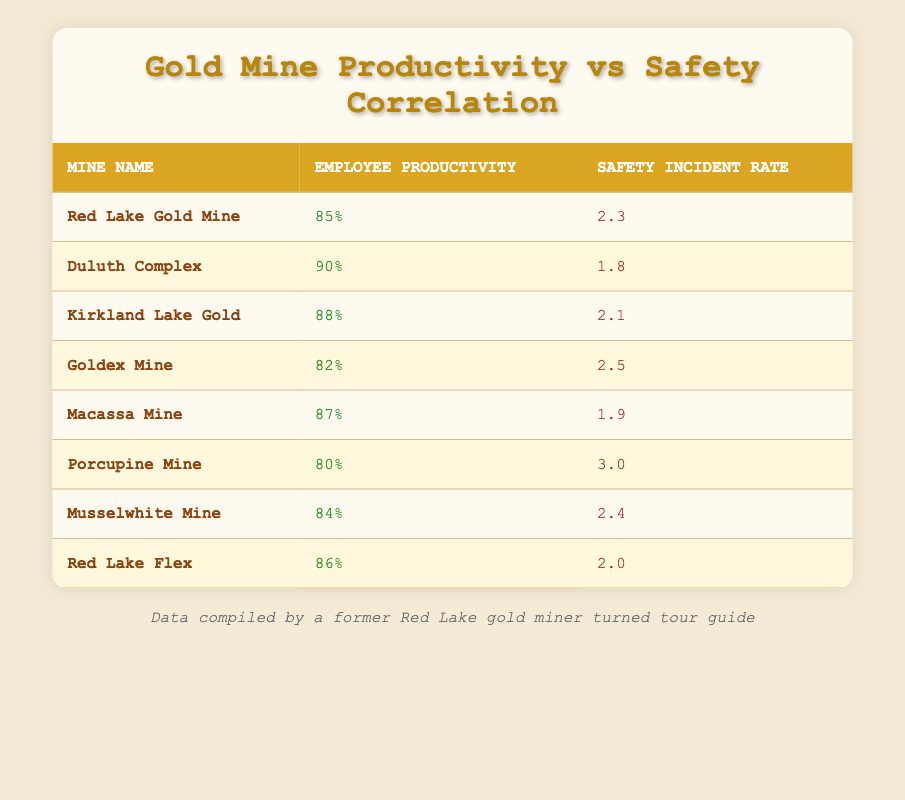What is the employee productivity percentage at Red Lake Gold Mine? The table lists the productivity for each mine. For Red Lake Gold Mine, the employee productivity is noted as 85%.
Answer: 85% Which mine has the lowest safety incident rate? By reviewing the safety incident rates in the table, Duluth Complex has the lowest rate at 1.8 incidents.
Answer: Duluth Complex What is the average employee productivity across all mines? To calculate the average, sum the productivity percentages: (85 + 90 + 88 + 82 + 87 + 80 + 84 + 86) =  692. There are 8 mines, so the average is 692 / 8 = 86.5.
Answer: 86.5 Is it true that Macassa Mine has a higher safety incident rate than Goldex Mine? According to the table, Macassa Mine has a safety incident rate of 1.9 while Goldex Mine has a rate of 2.5. Since 1.9 is lower than 2.5, the statement is false.
Answer: No What is the difference in incident rates between Porcupine Mine and Kirkland Lake Gold? The safety incident rate for Porcupine Mine is 3.0, and for Kirkland Lake Gold, it is 2.1. The difference is 3.0 - 2.1 = 0.9.
Answer: 0.9 How many mines have an employee productivity above 85%? By examining the productivity values, the mines with productivity above 85% are Duluth Complex (90), Kirkland Lake Gold (88), Macassa Mine (87), and Red Lake Flex (86), totaling 4 mines.
Answer: 4 What is the safety incident rate for the mine with the highest productivity? From the table, Duluth Complex has the highest productivity of 90%, with a corresponding safety incident rate of 1.8.
Answer: 1.8 Which mine has productivity percentage closest to the average productivity? The average productivity is 86.5, and the values that are closest are Red Lake Flex (86) and Macassa Mine (87), differing by 0.5 and 0.5, respectively.
Answer: Red Lake Flex and Macassa Mine 